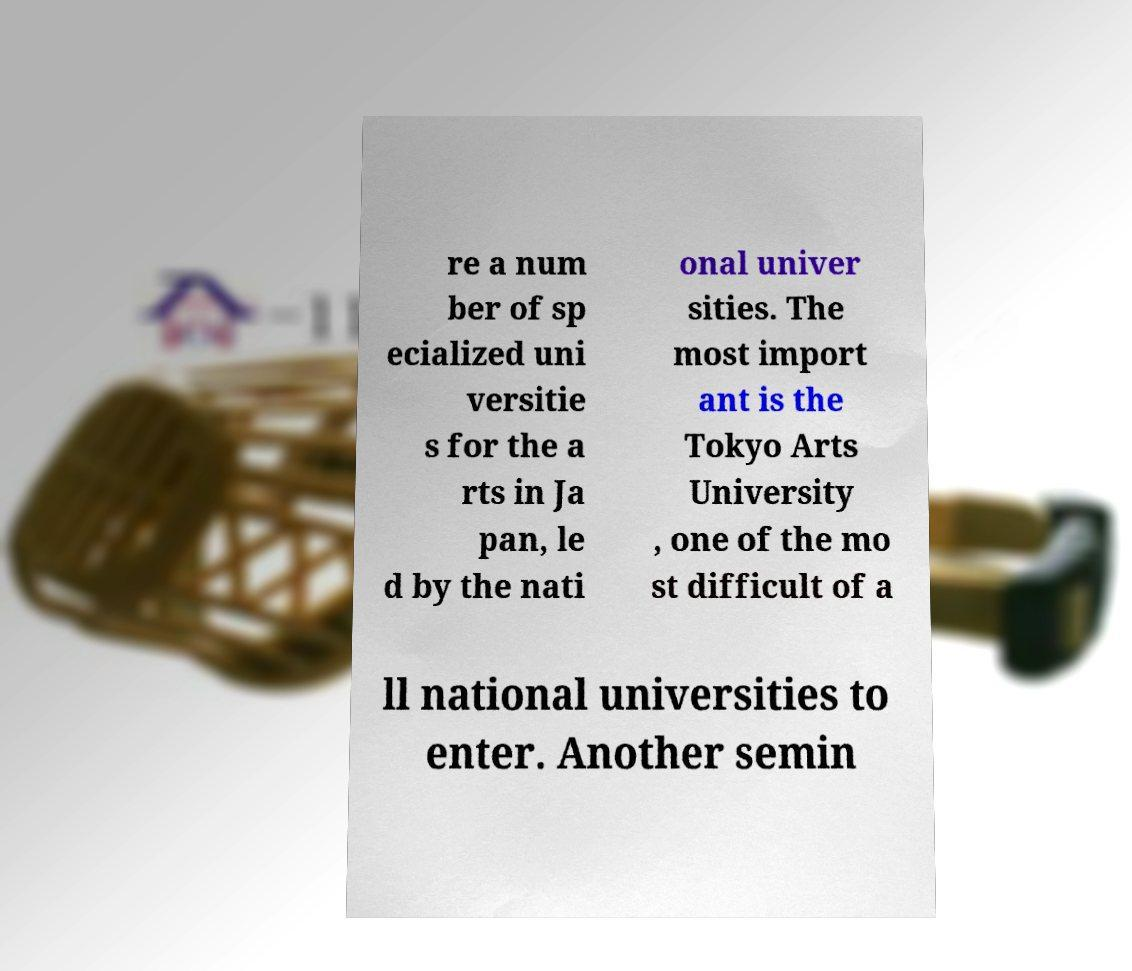Please read and relay the text visible in this image. What does it say? re a num ber of sp ecialized uni versitie s for the a rts in Ja pan, le d by the nati onal univer sities. The most import ant is the Tokyo Arts University , one of the mo st difficult of a ll national universities to enter. Another semin 